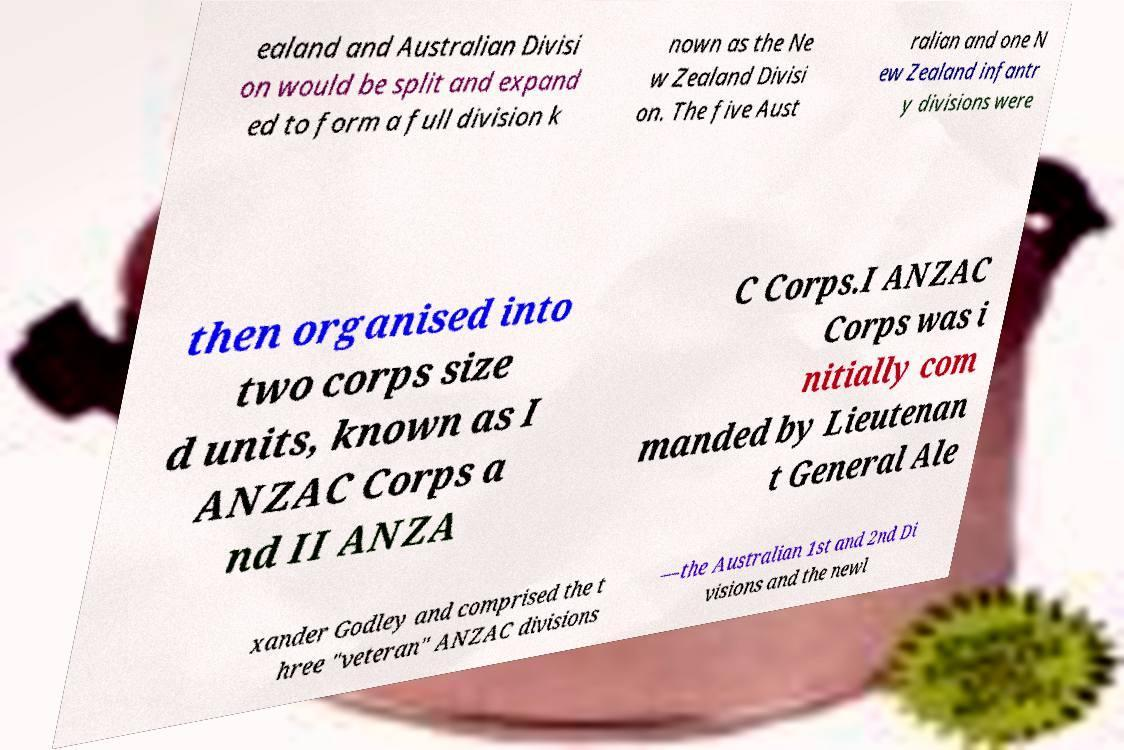Please identify and transcribe the text found in this image. ealand and Australian Divisi on would be split and expand ed to form a full division k nown as the Ne w Zealand Divisi on. The five Aust ralian and one N ew Zealand infantr y divisions were then organised into two corps size d units, known as I ANZAC Corps a nd II ANZA C Corps.I ANZAC Corps was i nitially com manded by Lieutenan t General Ale xander Godley and comprised the t hree "veteran" ANZAC divisions —the Australian 1st and 2nd Di visions and the newl 